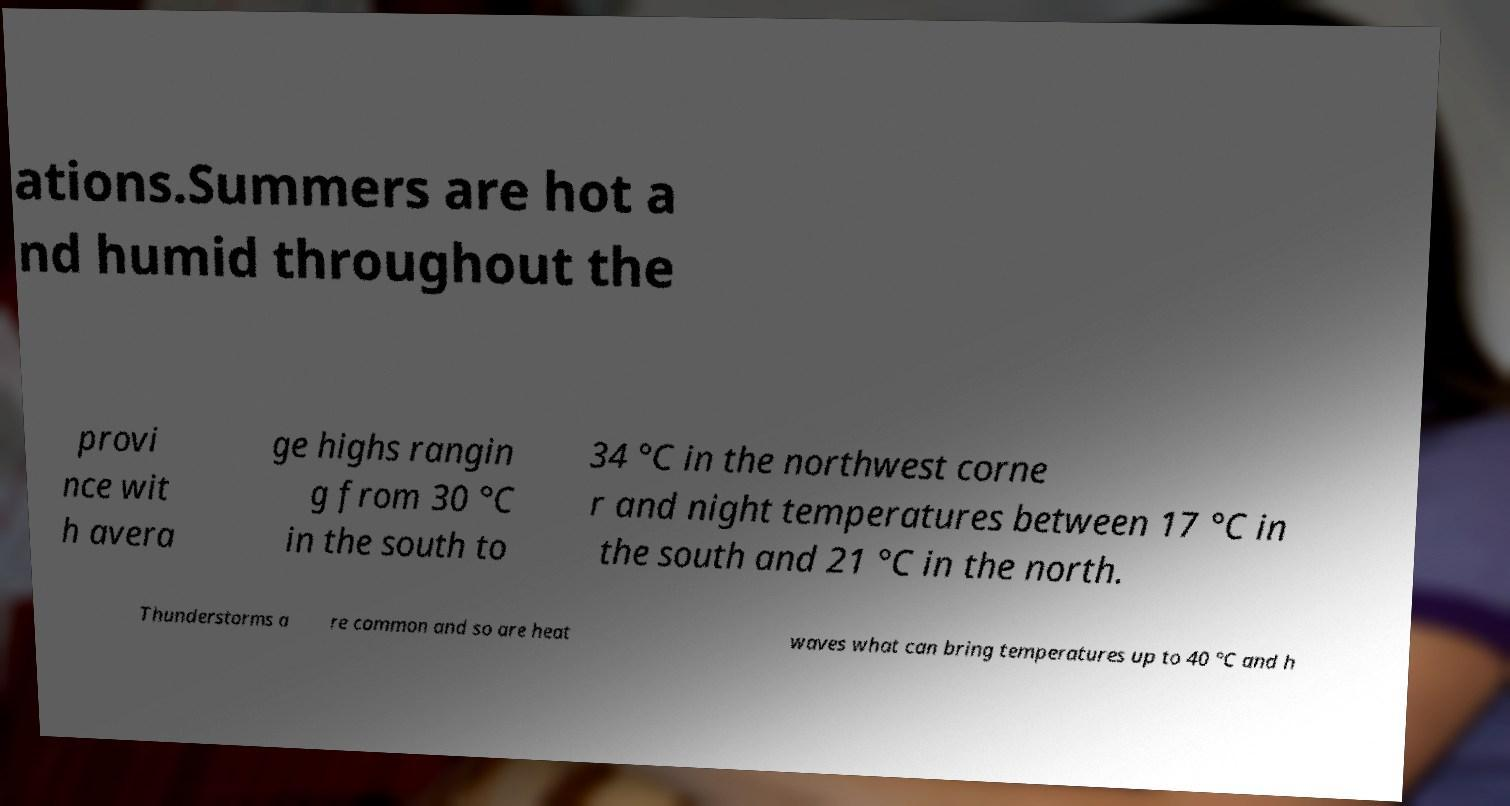Could you extract and type out the text from this image? ations.Summers are hot a nd humid throughout the provi nce wit h avera ge highs rangin g from 30 °C in the south to 34 °C in the northwest corne r and night temperatures between 17 °C in the south and 21 °C in the north. Thunderstorms a re common and so are heat waves what can bring temperatures up to 40 °C and h 